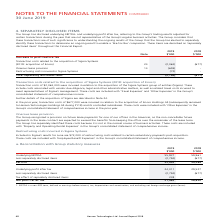According to Hansen Technologies's financial document, How much transaction cost was incurred to acquire Sigma Systems group of entities? According to the financial document, $2,063,000. The relevant text states: "Transaction costs of $2,063,000 were incurred in relation to the acquisition of the Sigma Systems group of entities (Sigma). These i..." Also, What was the transaction costs in 2018 comprised of? the acquisition of Enoro Holdings AS (subsequently renamed to Hansen Technologies Holdings AS during FY19) and its controlled subsidiaries.. The document states: "ion costs of $677,000 were incurred in relation to the acquisition of Enoro Holdings AS (subsequently renamed to Hansen Technologies Holdings AS durin..." Also, How much restructuring costs was incurred after acquisition of Sigma Systems? According to the financial document, $72,000. The relevant text states: "Included in Sigma’s results for June are $72,000 of restructuring costs related to certain redundancy payments post-acquisition. These costs are incl..." Also, can you calculate: What was the average transaction costs related to the acquisitions for both years? To answer this question, I need to perform calculations using the financial data. The calculation is: (2,063 + 677) / 2 , which equals 1370 (in thousands). This is based on the information: "of Sigma Systems (2018: acquisition of Enoro) 24 (2,063) (677) Systems (2018: acquisition of Enoro) 24 (2,063) (677)..." The key data points involved are: 2,063, 677. Also, can you calculate: What was the Transaction and restructuring costs incurred by the acquisition of Sigma Systems? Based on the calculation: 2,063 + 72 , the result is 2135 (in thousands). This is based on the information: "Restructuring costs incurred in Sigma Systems (72) - of Sigma Systems (2018: acquisition of Enoro) 24 (2,063) (677)..." The key data points involved are: 2,063, 72. Also, can you calculate: What was the difference in transaction costs between the acquisition of Enoro in 2018 and acquisition of Sigma Systems in 2019? Based on the calculation: 2,063 - 677 , the result is 1386 (in thousands). This is based on the information: "of Sigma Systems (2018: acquisition of Enoro) 24 (2,063) (677) Systems (2018: acquisition of Enoro) 24 (2,063) (677)..." The key data points involved are: 2,063, 677. 